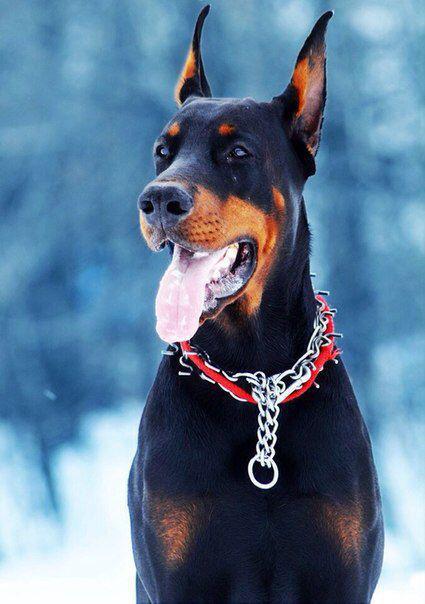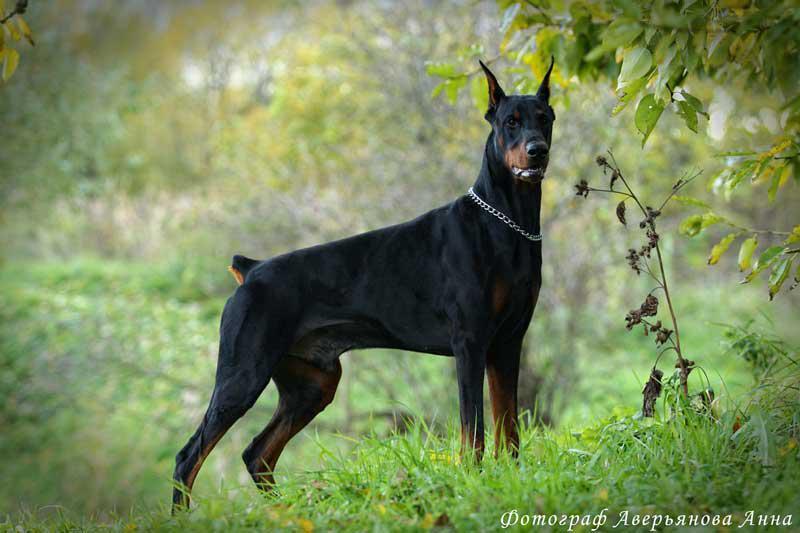The first image is the image on the left, the second image is the image on the right. Given the left and right images, does the statement "Each image features one adult doberman with erect ears and upright head, and the dog on the left wears something spiky around its neck." hold true? Answer yes or no. Yes. The first image is the image on the left, the second image is the image on the right. Evaluate the accuracy of this statement regarding the images: "The dog in the image on the left is wearing a collar and hanging its tongue out.". Is it true? Answer yes or no. Yes. 